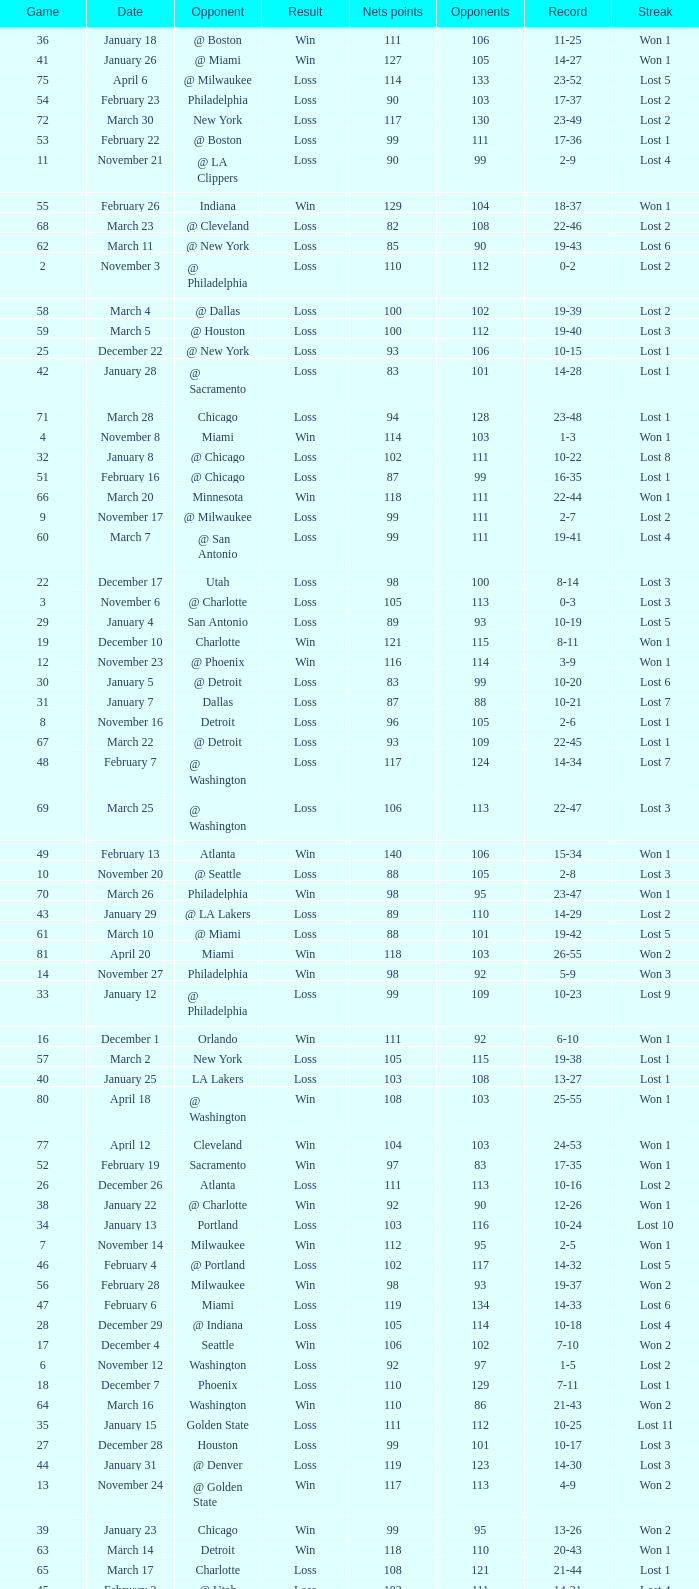What was the average point total for the nets in games before game 9 where the opponents scored less than 95? None. 